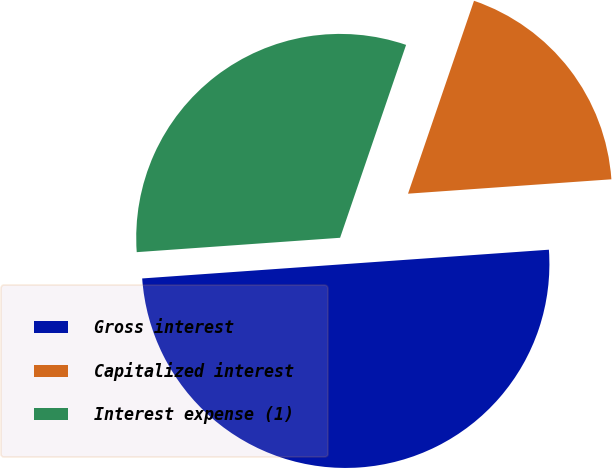Convert chart. <chart><loc_0><loc_0><loc_500><loc_500><pie_chart><fcel>Gross interest<fcel>Capitalized interest<fcel>Interest expense (1)<nl><fcel>50.0%<fcel>18.63%<fcel>31.37%<nl></chart> 